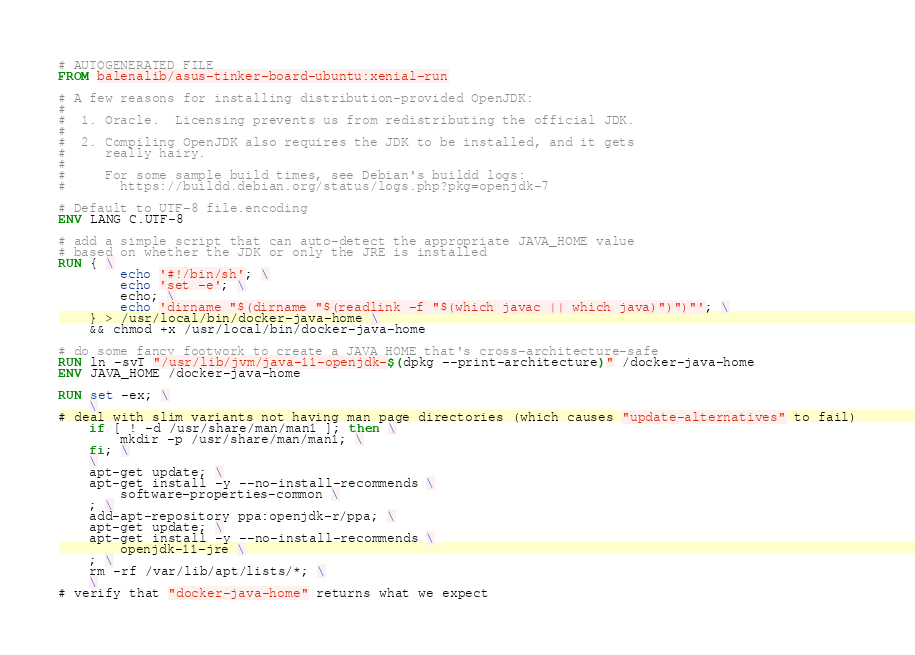Convert code to text. <code><loc_0><loc_0><loc_500><loc_500><_Dockerfile_># AUTOGENERATED FILE
FROM balenalib/asus-tinker-board-ubuntu:xenial-run

# A few reasons for installing distribution-provided OpenJDK:
#
#  1. Oracle.  Licensing prevents us from redistributing the official JDK.
#
#  2. Compiling OpenJDK also requires the JDK to be installed, and it gets
#     really hairy.
#
#     For some sample build times, see Debian's buildd logs:
#       https://buildd.debian.org/status/logs.php?pkg=openjdk-7

# Default to UTF-8 file.encoding
ENV LANG C.UTF-8

# add a simple script that can auto-detect the appropriate JAVA_HOME value
# based on whether the JDK or only the JRE is installed
RUN { \
		echo '#!/bin/sh'; \
		echo 'set -e'; \
		echo; \
		echo 'dirname "$(dirname "$(readlink -f "$(which javac || which java)")")"'; \
	} > /usr/local/bin/docker-java-home \
	&& chmod +x /usr/local/bin/docker-java-home

# do some fancy footwork to create a JAVA_HOME that's cross-architecture-safe
RUN ln -svT "/usr/lib/jvm/java-11-openjdk-$(dpkg --print-architecture)" /docker-java-home
ENV JAVA_HOME /docker-java-home

RUN set -ex; \
	\
# deal with slim variants not having man page directories (which causes "update-alternatives" to fail)
	if [ ! -d /usr/share/man/man1 ]; then \
		mkdir -p /usr/share/man/man1; \
	fi; \
	\
	apt-get update; \
	apt-get install -y --no-install-recommends \
		software-properties-common \
	; \
	add-apt-repository ppa:openjdk-r/ppa; \
	apt-get update; \
	apt-get install -y --no-install-recommends \
		openjdk-11-jre \
	; \
	rm -rf /var/lib/apt/lists/*; \
	\
# verify that "docker-java-home" returns what we expect</code> 